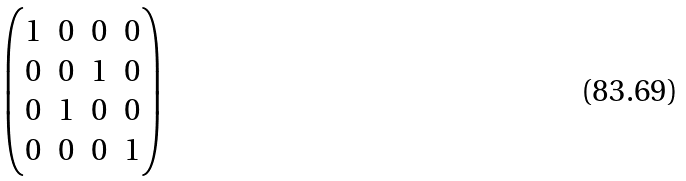Convert formula to latex. <formula><loc_0><loc_0><loc_500><loc_500>\begin{pmatrix} 1 & 0 & 0 & 0 \\ 0 & 0 & 1 & 0 \\ 0 & 1 & 0 & 0 \\ 0 & 0 & 0 & 1 \end{pmatrix}</formula> 